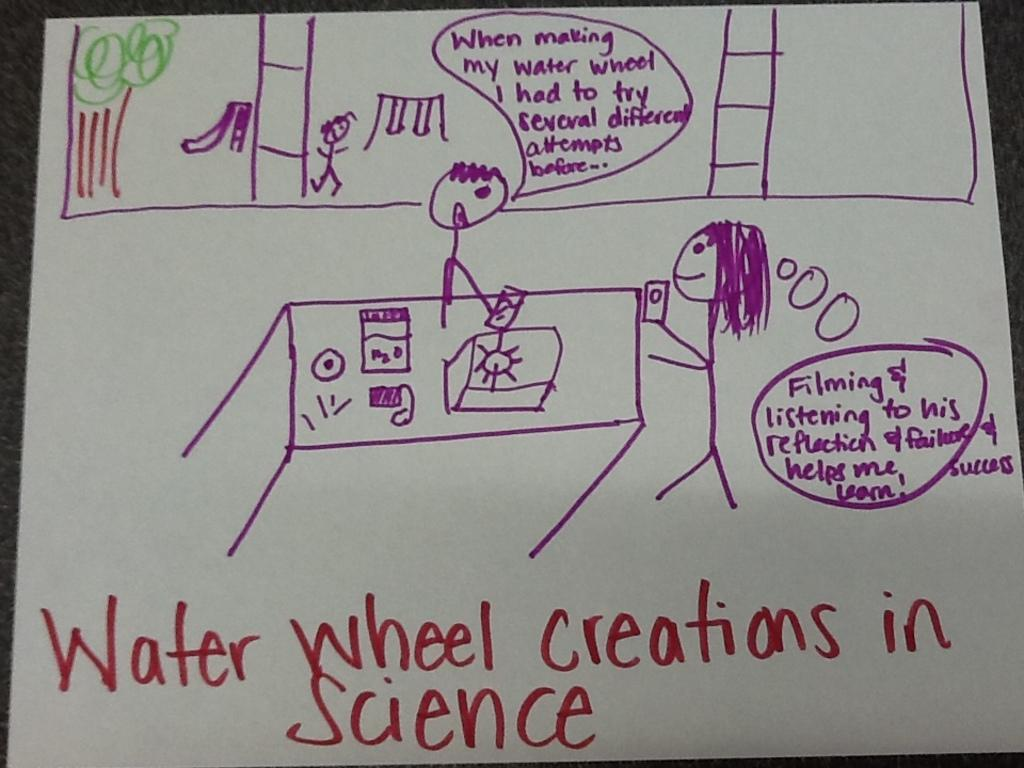What is on the white paper in the image? There is a drawing and text on the white paper. Can you describe the drawing on the white paper? Unfortunately, the details of the drawing cannot be determined from the image alone. What is the content of the text on the white paper? The content of the text cannot be determined from the image alone. What type of silverware is depicted in the drawing on the white paper? There is no silverware depicted in the drawing on the white paper, as the drawing's content cannot be determined from the image alone. 